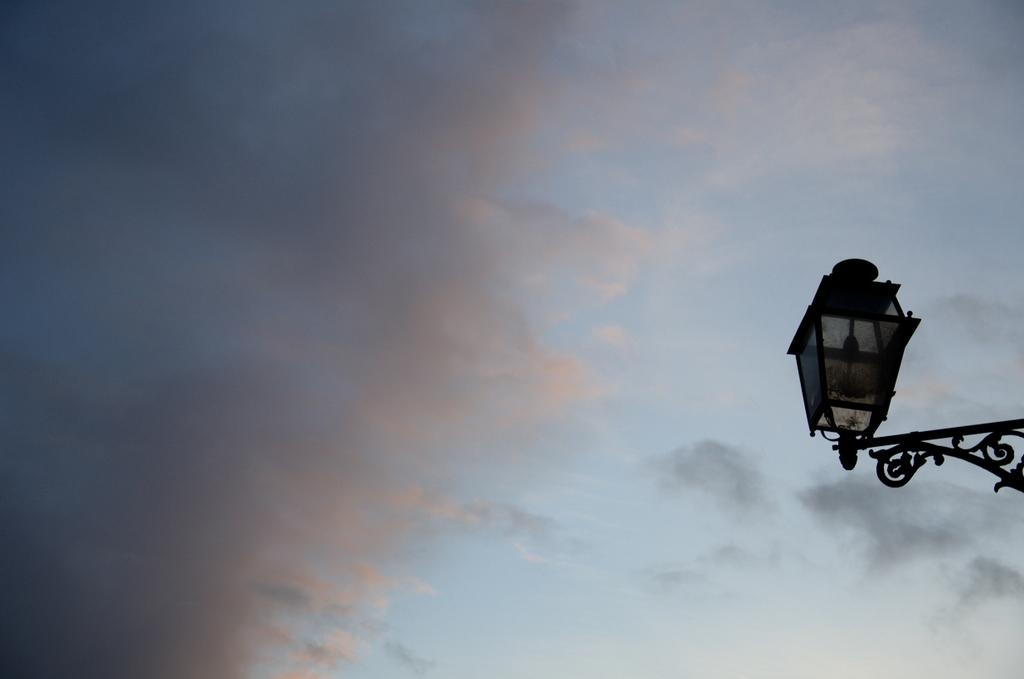What object is located on the right side of the image? There is a lamp on the right side of the image. What is visible at the top of the image? The sky is visible at the top of the image. Can you describe the sky in the image? The sky appears to be cloudy. Is there a maid cleaning the lamp in the image? There is no maid present in the image, nor is there any indication of cleaning or maintenance being performed on the lamp. 